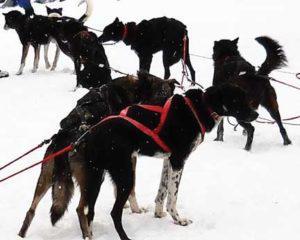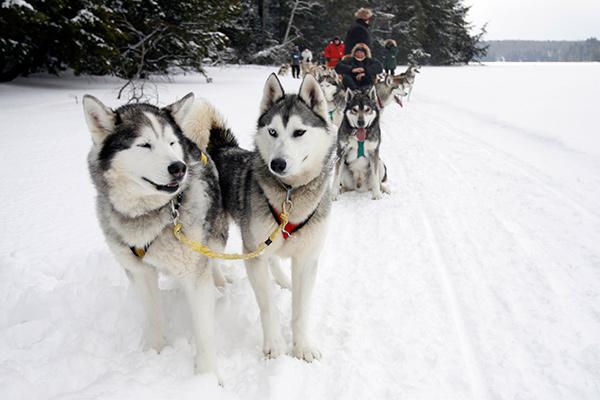The first image is the image on the left, the second image is the image on the right. For the images displayed, is the sentence "Most of the dogs in one of the images are wearing boots." factually correct? Answer yes or no. No. The first image is the image on the left, the second image is the image on the right. Considering the images on both sides, is "Most of the dogs on one sled team are wearing black booties with a white band across the top." valid? Answer yes or no. No. 